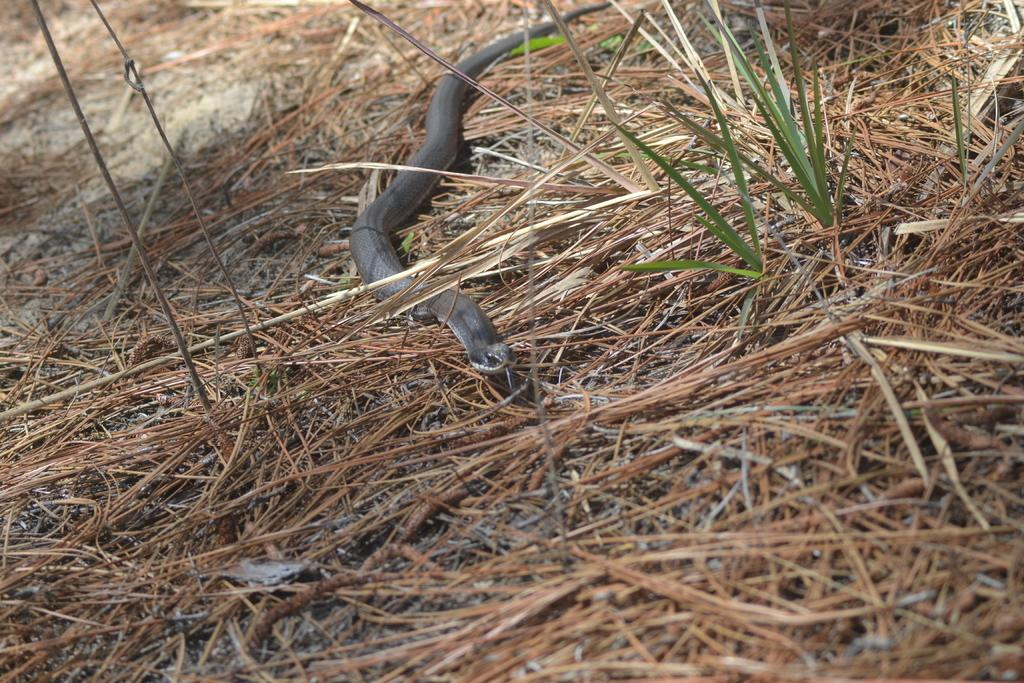What animal is present in the image? There is a snake in the image. Where is the snake located? The snake is on the ground. What type of vegetation can be seen in the image? There is grass visible in the image. What type of cloud is visible in the image? There is no cloud visible in the image; it only features a snake on the ground and grass. 